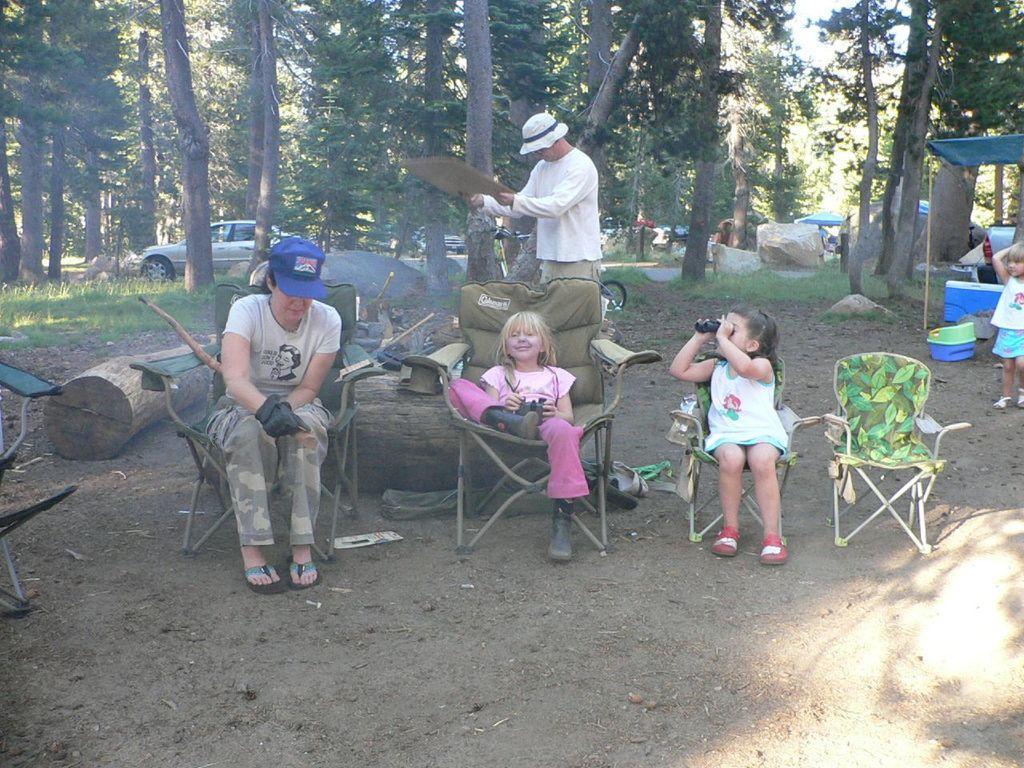In one or two sentences, can you explain what this image depicts? This picture shows a woman and two children seated on the chairs and we see a man standing and a girl standing on the side and we see a trees around and a car parked 